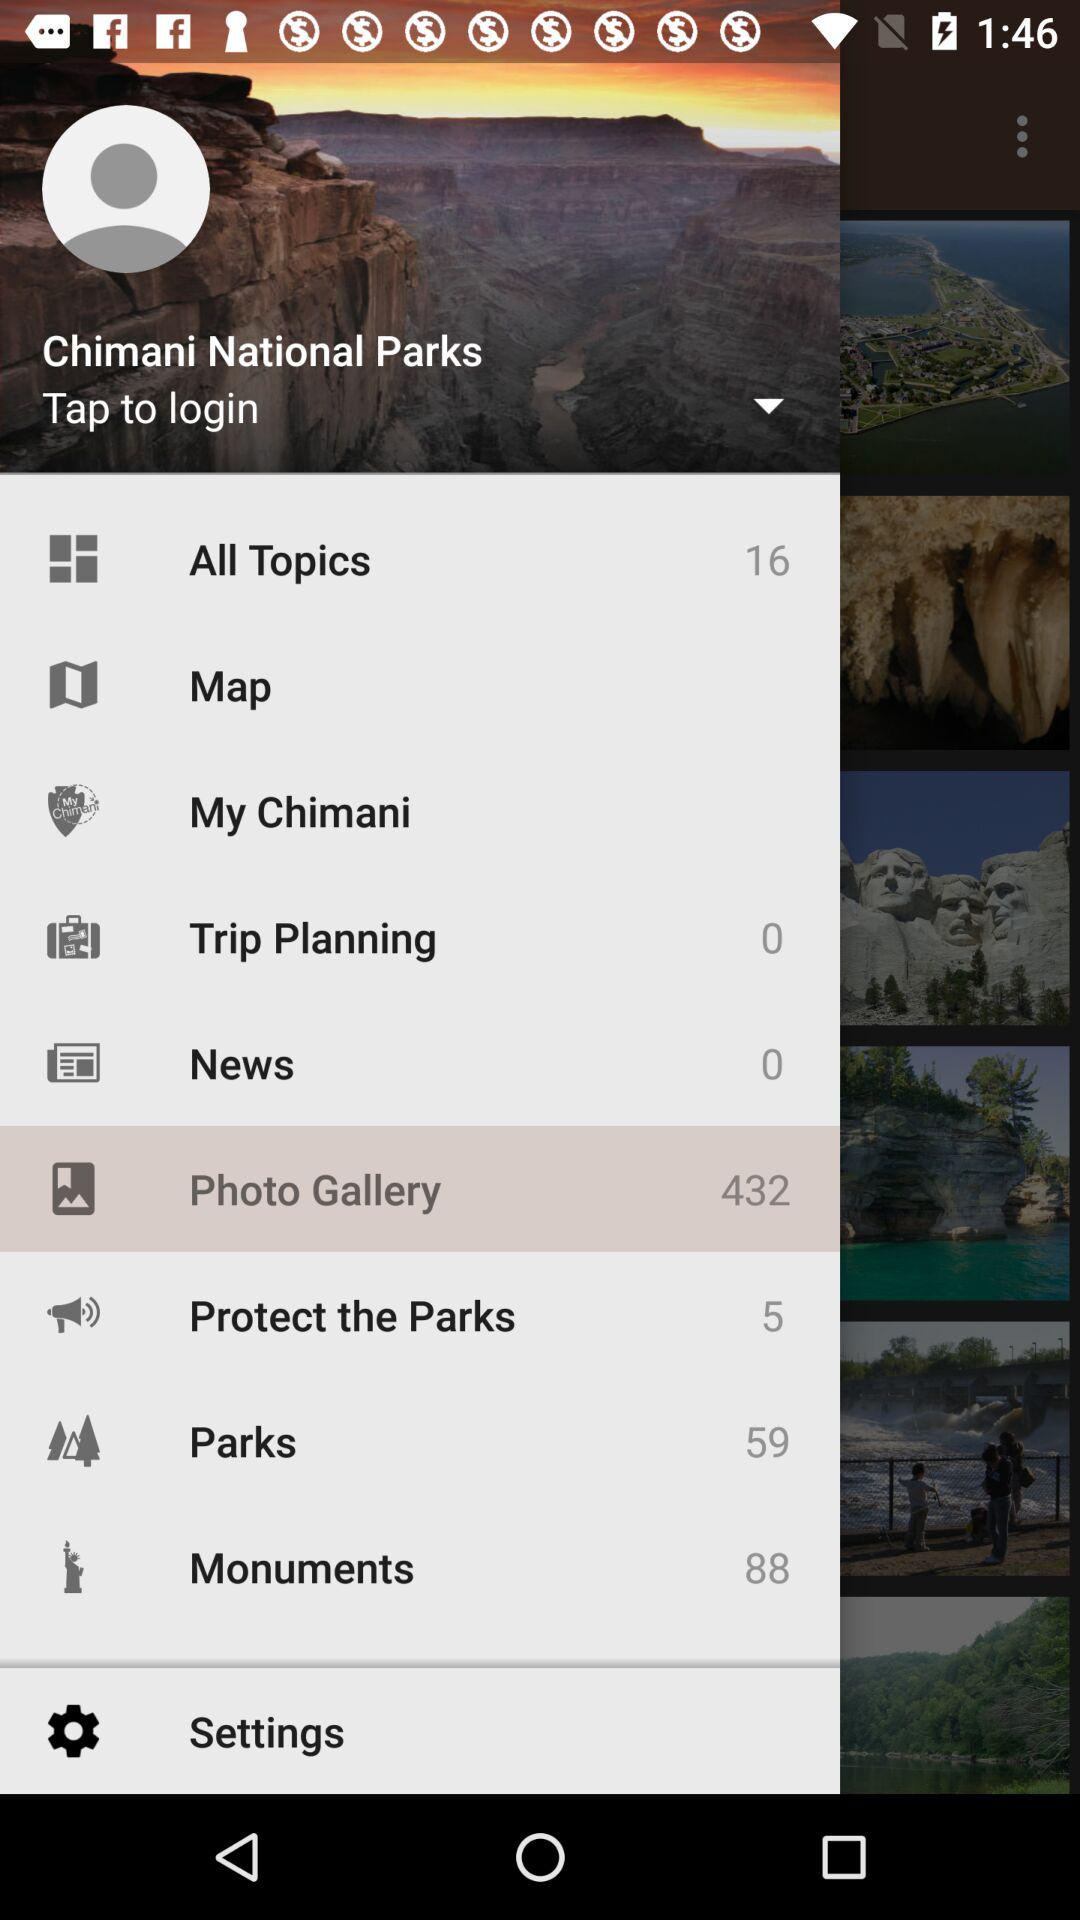How many photos are there in the "Photo Gallery"? There are 432 photos in the "Photo Gallery". 